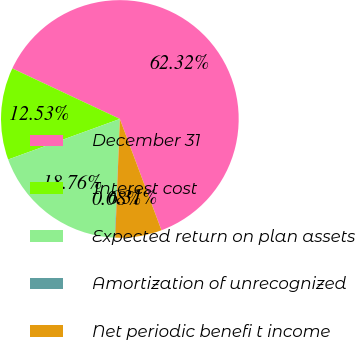<chart> <loc_0><loc_0><loc_500><loc_500><pie_chart><fcel>December 31<fcel>Interest cost<fcel>Expected return on plan assets<fcel>Amortization of unrecognized<fcel>Net periodic benefi t income<nl><fcel>62.32%<fcel>12.53%<fcel>18.76%<fcel>0.08%<fcel>6.31%<nl></chart> 